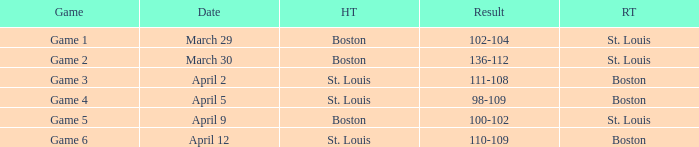What Game had a Result of 136-112? Game 2. 